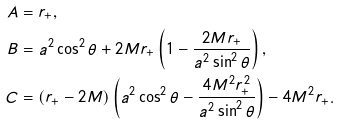Convert formula to latex. <formula><loc_0><loc_0><loc_500><loc_500>A & = r _ { + } , \\ B & = a ^ { 2 } \cos ^ { 2 } \theta + 2 M r _ { + } \left ( 1 - \frac { 2 M r _ { + } } { a ^ { 2 } \sin ^ { 2 } \theta } \right ) , \\ C & = ( r _ { + } - 2 M ) \left ( a ^ { 2 } \cos ^ { 2 } \theta - \frac { 4 M ^ { 2 } r _ { + } ^ { 2 } } { a ^ { 2 } \sin ^ { 2 } \theta } \right ) - 4 M ^ { 2 } r _ { + } .</formula> 